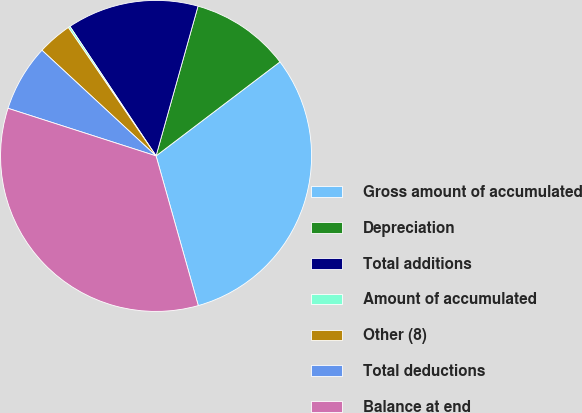<chart> <loc_0><loc_0><loc_500><loc_500><pie_chart><fcel>Gross amount of accumulated<fcel>Depreciation<fcel>Total additions<fcel>Amount of accumulated<fcel>Other (8)<fcel>Total deductions<fcel>Balance at end<nl><fcel>30.96%<fcel>10.32%<fcel>13.69%<fcel>0.2%<fcel>3.57%<fcel>6.94%<fcel>34.33%<nl></chart> 